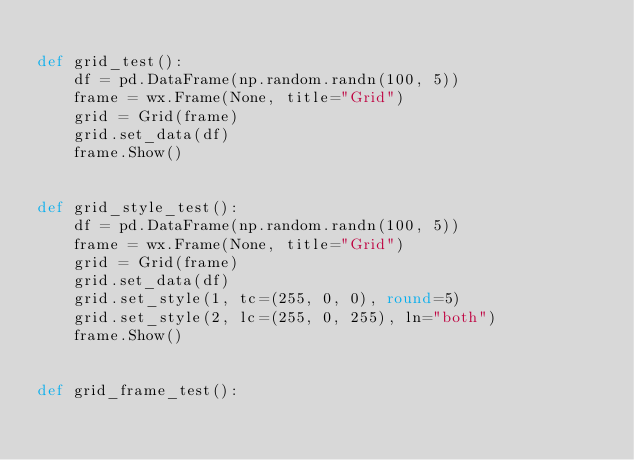<code> <loc_0><loc_0><loc_500><loc_500><_Python_>
def grid_test():
    df = pd.DataFrame(np.random.randn(100, 5))
    frame = wx.Frame(None, title="Grid")
    grid = Grid(frame)
    grid.set_data(df)
    frame.Show()


def grid_style_test():
    df = pd.DataFrame(np.random.randn(100, 5))
    frame = wx.Frame(None, title="Grid")
    grid = Grid(frame)
    grid.set_data(df)
    grid.set_style(1, tc=(255, 0, 0), round=5)
    grid.set_style(2, lc=(255, 0, 255), ln="both")
    frame.Show()


def grid_frame_test():</code> 